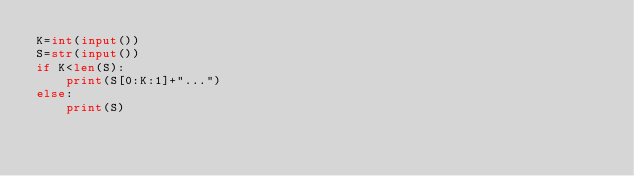Convert code to text. <code><loc_0><loc_0><loc_500><loc_500><_Python_>K=int(input())
S=str(input())
if K<len(S):
    print(S[0:K:1]+"...")
else:
    print(S)
</code> 